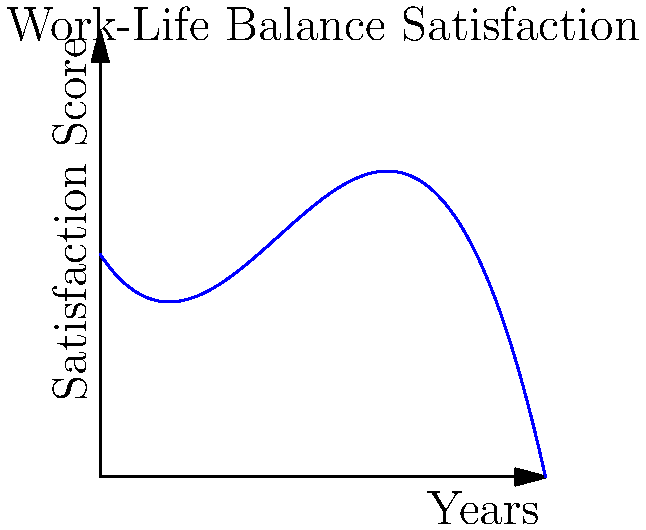The graph represents a senior manager's work-life balance satisfaction scores over a 10-year period at a tech company. If the current satisfaction score is 7, and the trend continues, approximately how many years will it take for the satisfaction score to return to its initial level? To solve this problem, we need to follow these steps:

1. Identify the initial satisfaction score:
   From the graph, we can see that at year 0, the satisfaction score is 5.

2. Locate the current satisfaction score:
   The question states that the current score is 7.

3. Trace the curve to find when it returns to the initial level:
   Following the curve from the point where it crosses 7 on the y-axis, we need to find where it intersects with y = 5 again.

4. Estimate the time difference:
   The curve intersects y = 7 at approximately 3 years.
   It then intersects y = 5 again at approximately 8 years.

5. Calculate the time difference:
   8 years - 3 years = 5 years

Therefore, if the trend continues, it will take approximately 5 years for the satisfaction score to return to its initial level of 5.
Answer: Approximately 5 years 